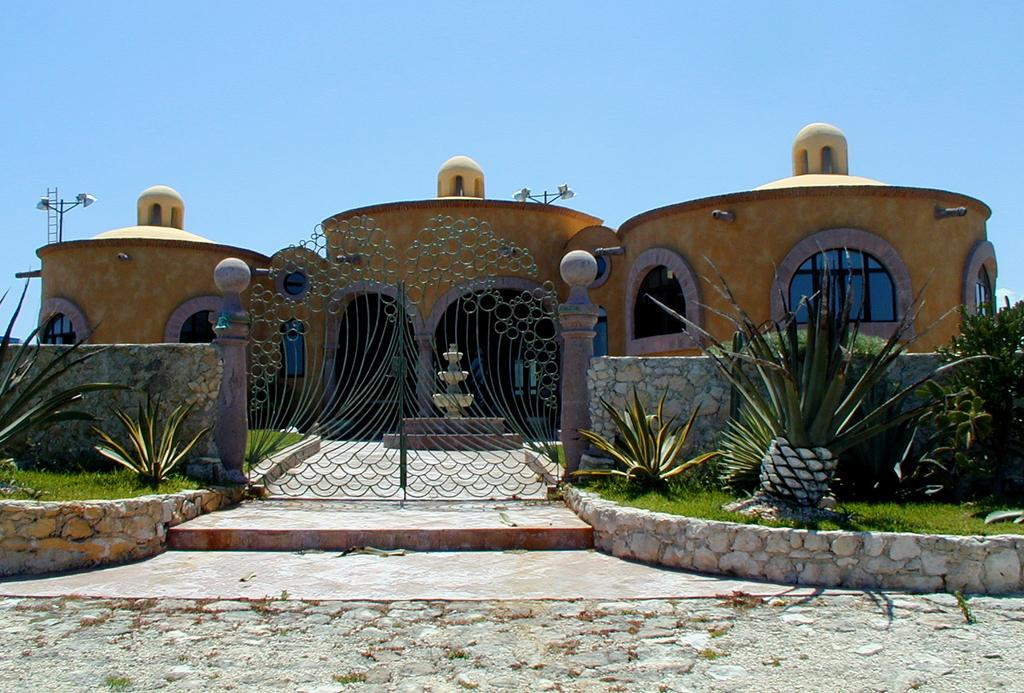What is: What is the main structure in the center of the image? There is a building in the center of the image. What material is present in the image that is transparent? Glass is present in the image. What type of barrier can be seen in the image? There is a wall in the image. What water feature is visible in the image? A fountain is visible in the image. What tool is used for climbing in the image? There is a ladder in the image. What type of entrance is present in the image? A gate is present in the image. What type of wall surrounds the compound in the image? A compound wall is in the image. What type of pathway is visible in the image? A road is visible in the image. What type of lighting is present in the image? Lamps are in the image. What type of vegetation is present in the image? Plants are present in the image. What type of ground cover is visible in the image? Grass is visible in the image. What can be seen in the background of the image? The sky is visible in the background. How does the sack of potatoes contribute to the comparison between the two buildings in the image? There is no sack of potatoes present in the image, and therefore no comparison can be made between two buildings. 